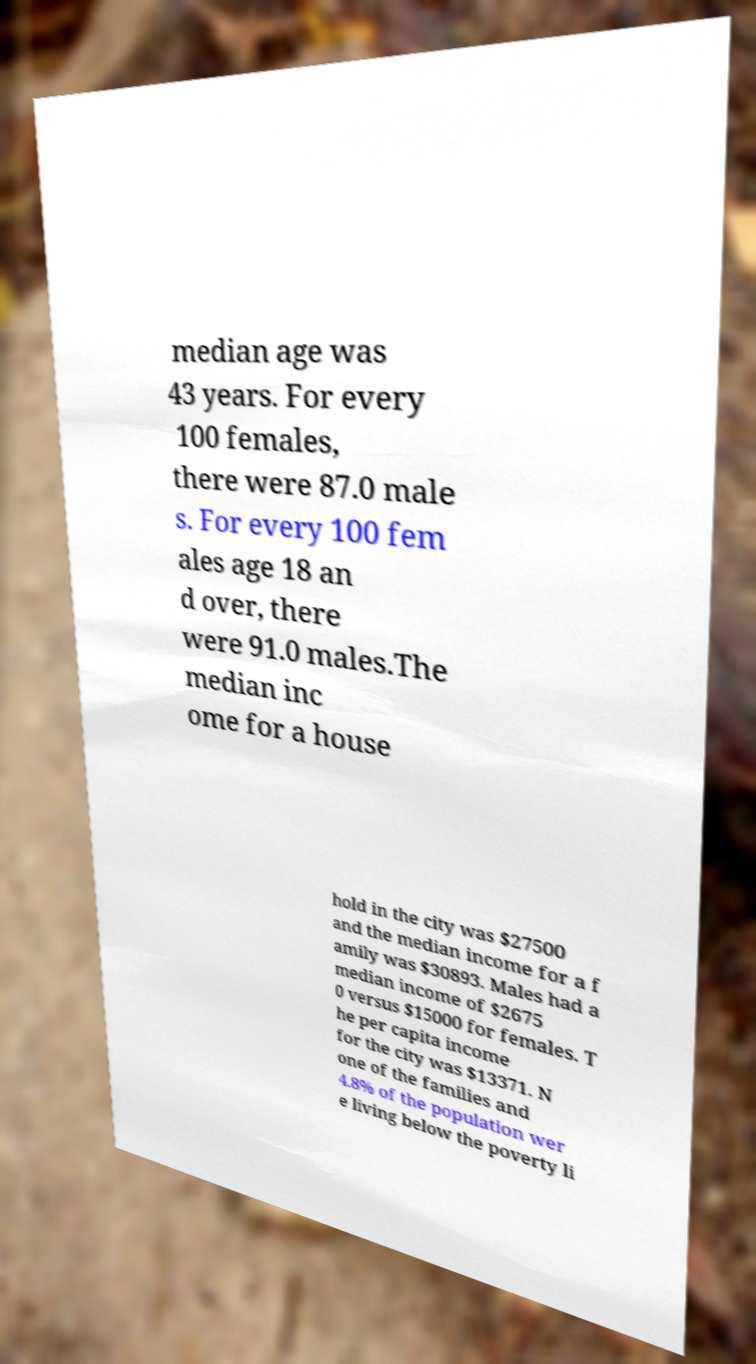Could you extract and type out the text from this image? median age was 43 years. For every 100 females, there were 87.0 male s. For every 100 fem ales age 18 an d over, there were 91.0 males.The median inc ome for a house hold in the city was $27500 and the median income for a f amily was $30893. Males had a median income of $2675 0 versus $15000 for females. T he per capita income for the city was $13371. N one of the families and 4.8% of the population wer e living below the poverty li 